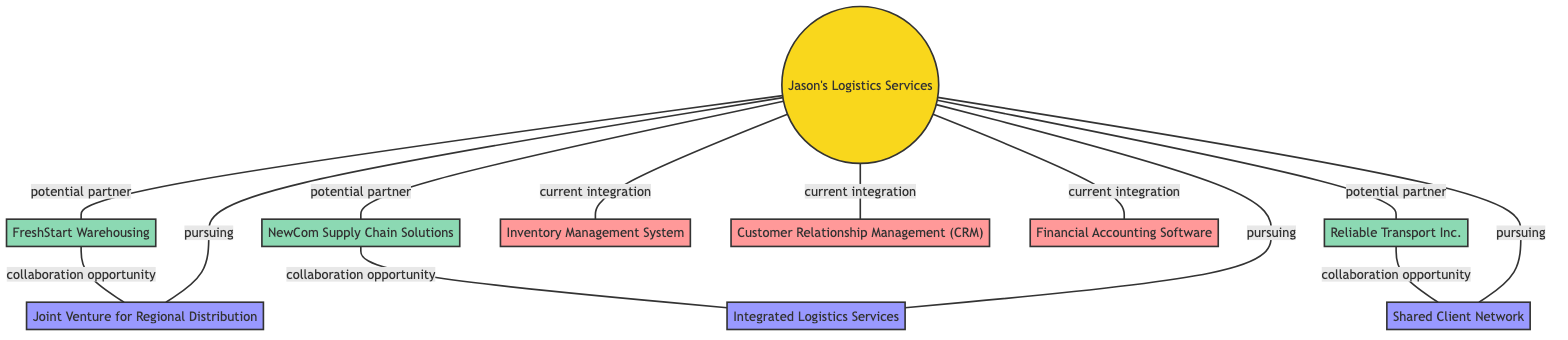What is the main business represented in the diagram? The diagram presents "Jason's Logistics Services" as the central business node. This can be identified as the node labeled specifically with that name and highlighted as the primary subject of the diagram.
Answer: Jason's Logistics Services How many partners are identified in the diagram? There are three partner nodes linked to the main business node, which can be counted directly from the edges connecting the business to each partnership node.
Answer: 3 Which integration systems is Jason's Logistics Services currently using? The current integrations listed in the diagram include "Inventory Management System", "Customer Relationship Management (CRM)", and "Financial Accounting Software". These are clearly shown as connected to the main business node under the label "current integration".
Answer: Inventory Management System, Customer Relationship Management (CRM), Financial Accounting Software What collaboration opportunity is linked to FreshStart Warehousing? The diagram shows that "Joint Venture for Regional Distribution" is the collaboration opportunity linked to FreshStart Warehousing, indicated by the edge labeled "collaboration opportunity" connecting them.
Answer: Joint Venture for Regional Distribution Which opportunity is pursued by Jason's Logistics Services related to newly established supply chain solutions? According to the diagram, the "Integrated Logistics Services" opportunity is linked to NewCom Supply Chain Solutions, and the node labeled "pursuing" connects Jason's Logistics Services to this opportunity.
Answer: Integrated Logistics Services What is the relationship type between Jason's Logistics Services and Reliable Transport Inc.? The diagram indicates a "potential partner" relationship between Jason's Logistics Services and Reliable Transport Inc., shown by the edge labeled accordingly connecting them.
Answer: potential partner Which opportunity is not linked to any partner in the network? The "Shared Client Network" opportunity is directly associated with Jason's Logistics Services but does not have a specified partner connected through a labeled edge.
Answer: Shared Client Network Which partner is not connected to the "Integrated Logistics Services" opportunity? From the diagram, it is evident that "Reliable Transport Inc." is connected to the "Shared Client Network" opportunity and not to the "Integrated Logistics Services" opportunity, which is solely linked to NewCom Supply Chain Solutions.
Answer: Reliable Transport Inc 